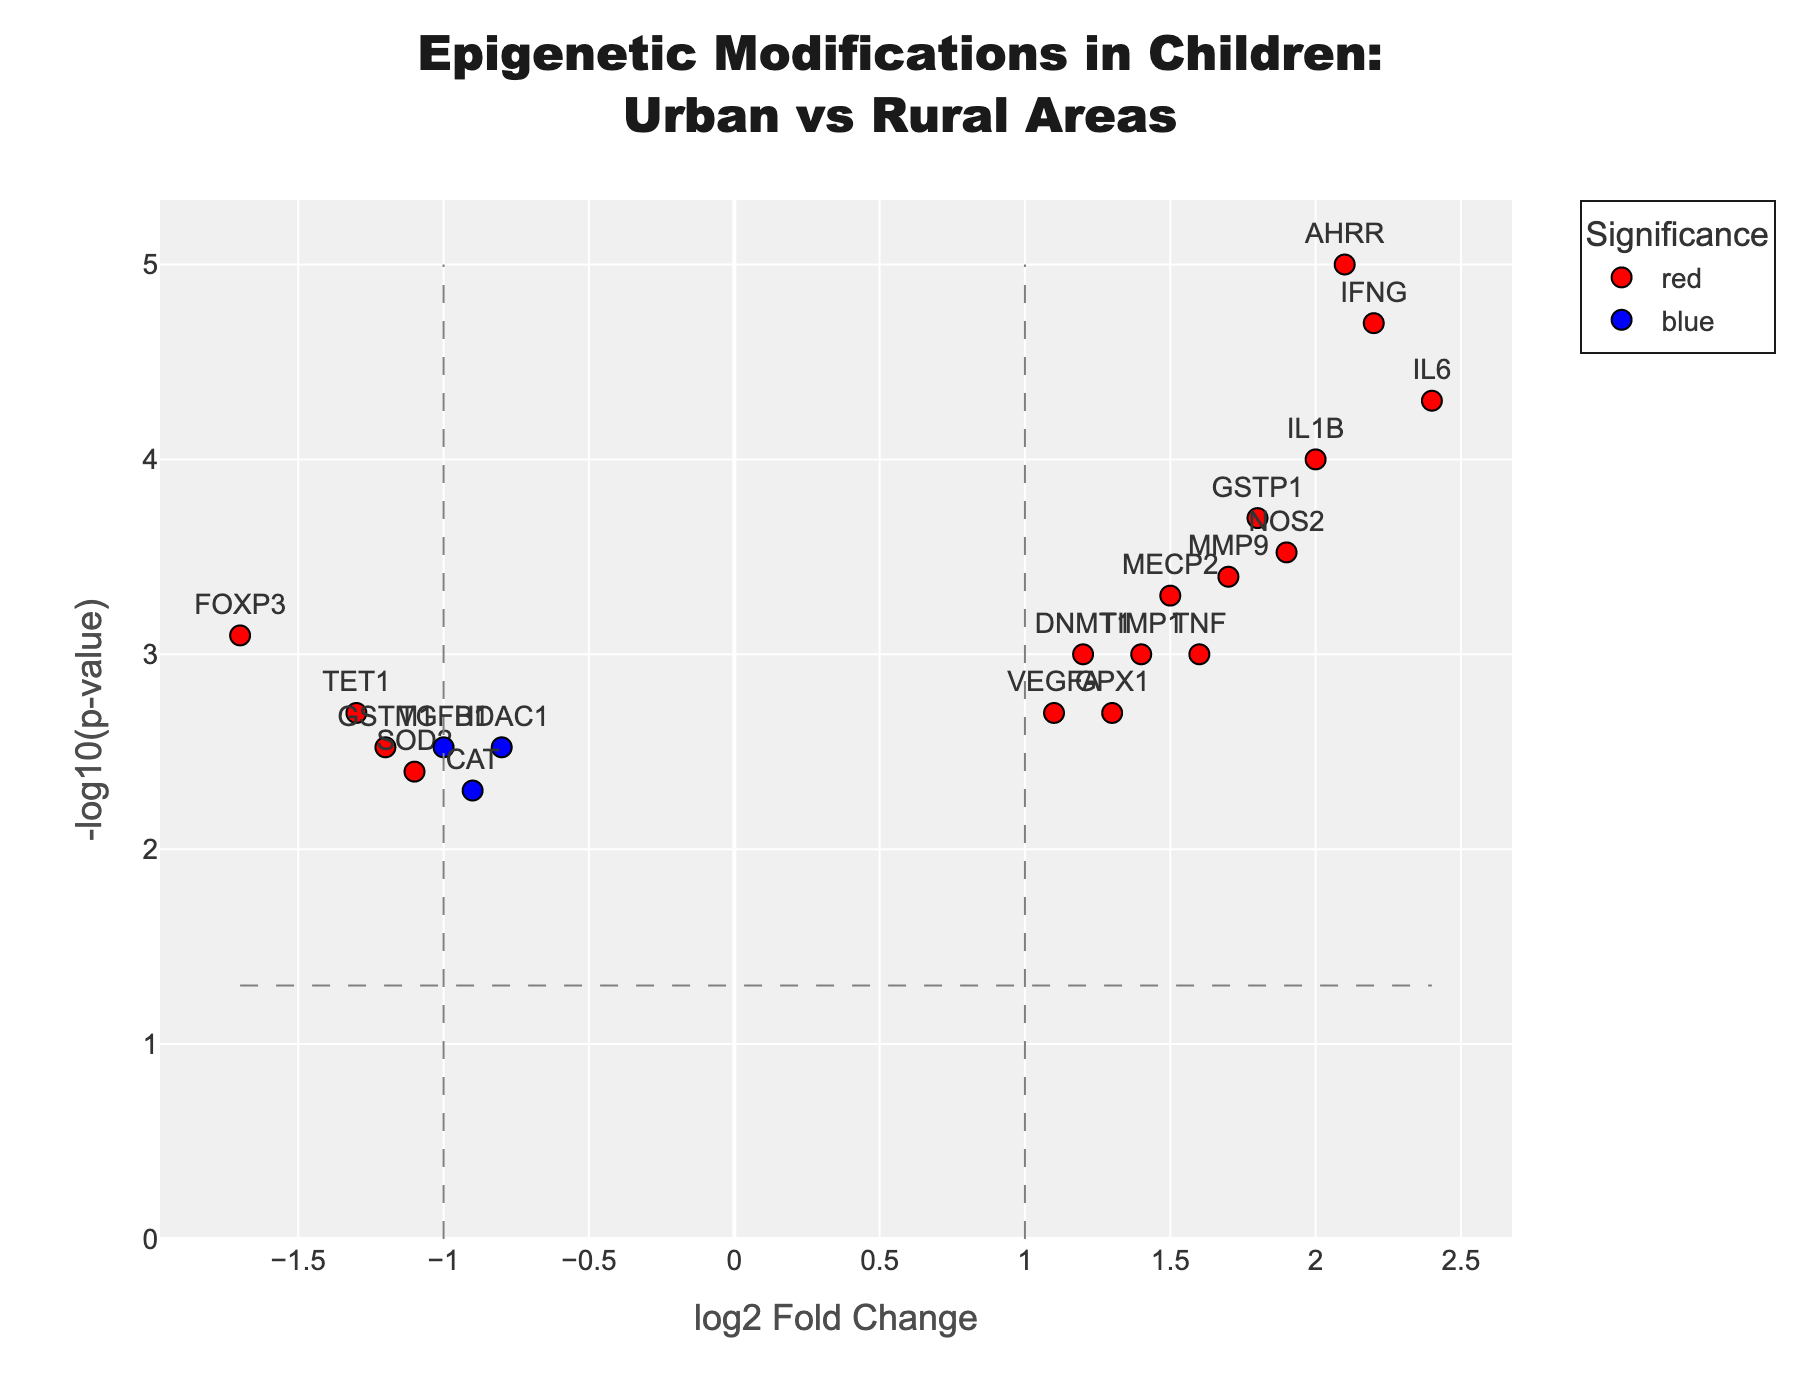what's the title of the volcano plot? The title of the plot is located at the top center and gives a brief description of what the plot represents.
Answer: Epigenetic Modifications in Children: Urban vs Rural Areas what are the axes labels in the volcano plot? The x-axis label indicates the log2 fold change and the y-axis label shows the -log10(p-value).
Answer: log2 Fold Change, -log10(p-value) how many genes are upregulated with a significant p-value? To find the upregulated and significant genes, look for red or green data points on the right side of the graph above the horizontal dashed line.
Answer: 9 which gene has the highest -log10(p-value)? Identify the data point with the highest y-coordinate and check its label.
Answer: AHRR which genes have a log2 fold change greater than 1 and are also statistically significant? Locate the data points with an x-coordinate greater than 1 and above the horizontal dashed line.
Answer: DNMT1, MECP2, AHRR, GSTP1, IL6, TNF, NOS2, IFNG, IL1B, TIMP1, MMP9, VEGFA how many genes have a log2 fold change less than -1? Count the data points on the left side of the x-axis threshold line at -1.
Answer: 5 what is the color of genes with a p-value above the significance threshold but with a significant log2 fold change? Check the legend or annotation for the color associated with data points that are significant in log2 fold change but not in p-value.
Answer: Green among the genes with significant downregulation, which one has the lowest p-value? Identify data points on the left of -1 log2 fold change threshold, then find the one with the highest -log10(p-value).
Answer: TET1 which genes on the plot are marked in blue? These are genes with p-values below the threshold but absolute log2 fold changes not exceeding 1.
Answer: HDAC1, VEGFA, TNF, TET1, SOD2, MMP9 how many genes fall into the grey category? Find and count the genes represented by grey points, meaning they don't meet the set thresholds for fold change and p-values.
Answer: 3 